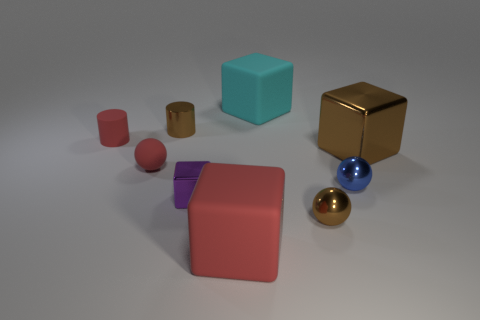How many gray objects are made of the same material as the tiny blue sphere?
Provide a short and direct response. 0. What is the shape of the big metal object that is the same color as the metallic cylinder?
Your answer should be very brief. Cube. Are there any other small blue objects that have the same shape as the tiny blue object?
Keep it short and to the point. No. There is a purple thing that is the same size as the blue sphere; what is its shape?
Provide a short and direct response. Cube. Does the tiny block have the same color as the object on the left side of the small red sphere?
Ensure brevity in your answer.  No. What number of balls are left of the small red thing behind the red matte sphere?
Offer a terse response. 0. There is a rubber object that is both on the right side of the tiny metallic cylinder and in front of the big metallic cube; what is its size?
Offer a very short reply. Large. Is there a red rubber sphere that has the same size as the brown ball?
Your answer should be very brief. Yes. Is the number of small red objects behind the tiny rubber cylinder greater than the number of tiny blue metal balls to the left of the tiny block?
Your response must be concise. No. Is the cyan object made of the same material as the tiny brown object behind the blue metallic sphere?
Offer a very short reply. No. 